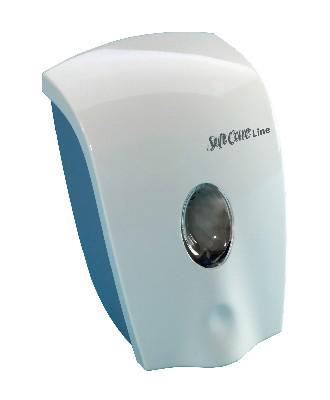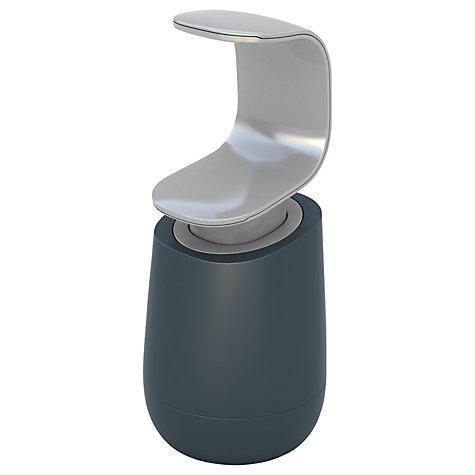The first image is the image on the left, the second image is the image on the right. Assess this claim about the two images: "the dispenser button in the image on the left is light gray". Correct or not? Answer yes or no. No. 